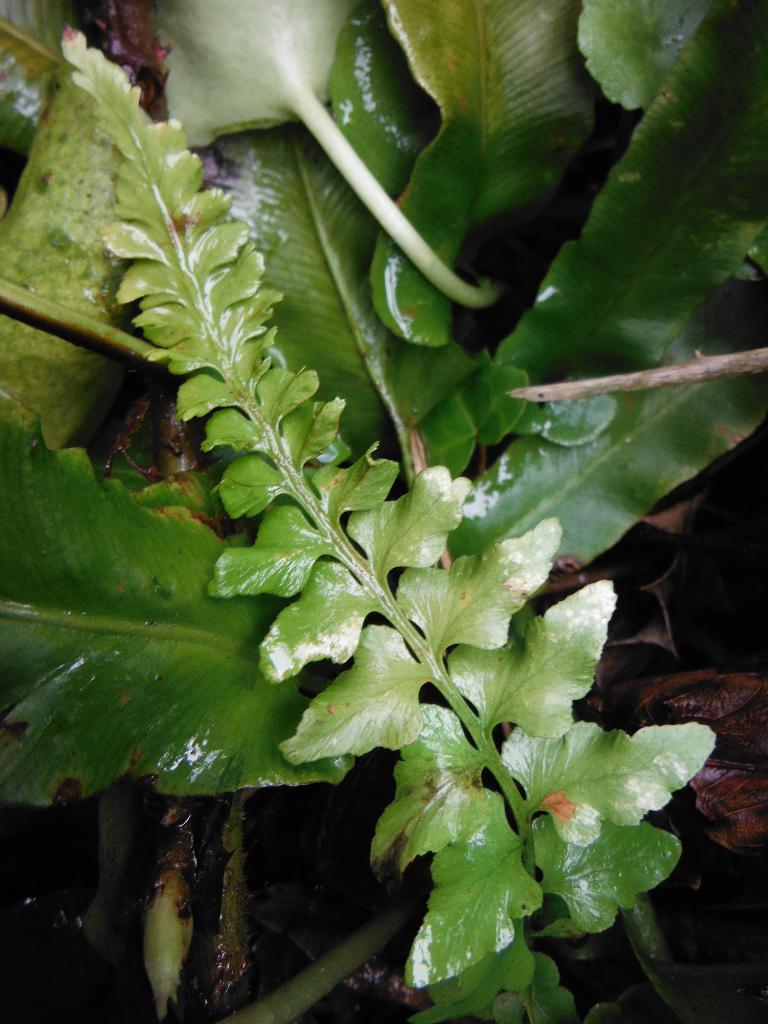What is present in the image? There is a plant in the image. What specific part of the plant can be seen? The plant has leaves. Where can the queen be seen wearing her ring in the image? There is no queen or ring present in the image; it only features a plant with leaves. 